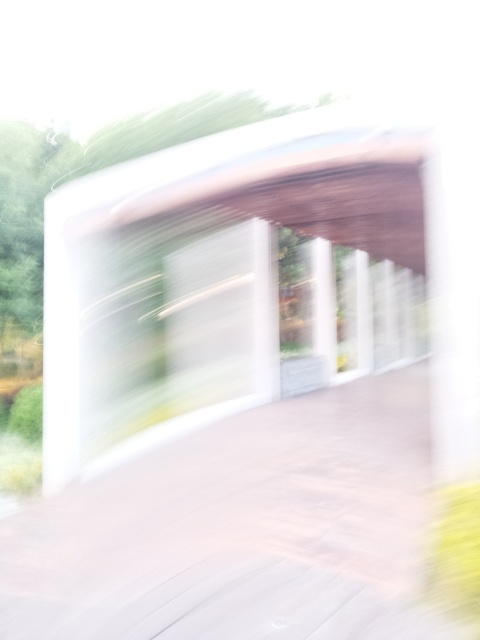What is the quality of this image?
A. Very poor
B. Average
C. Good
D. Excellent The quality of the image can be considered very poor (Option A). This assessment is due to the significant blurring and the lack of clear details, making it difficult to discern specific features or subjects within the photo. The image does not have the sharpness or clarity expected in a high-quality photograph. 